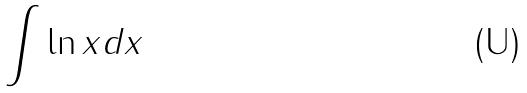Convert formula to latex. <formula><loc_0><loc_0><loc_500><loc_500>\int \ln x d x</formula> 